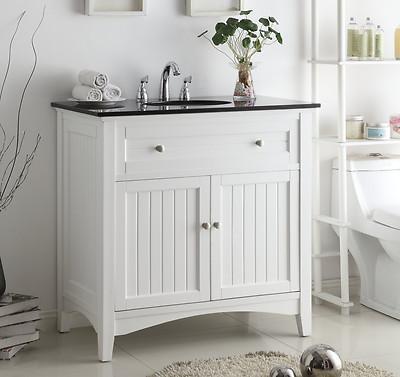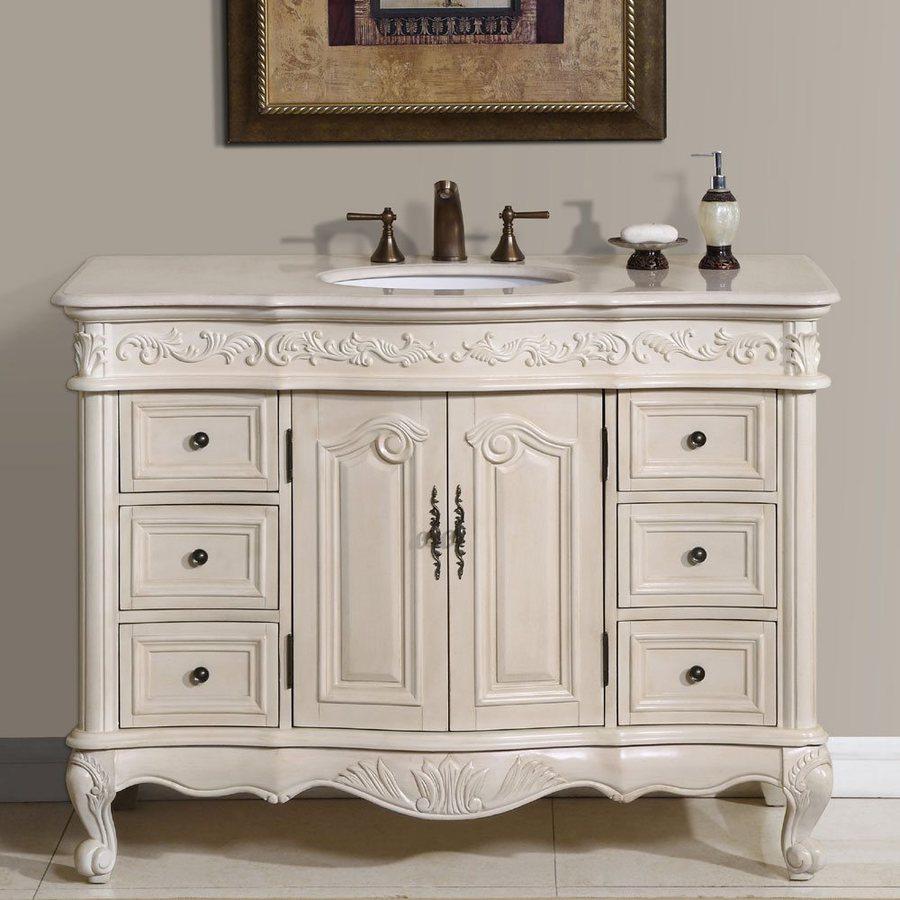The first image is the image on the left, the second image is the image on the right. Assess this claim about the two images: "Both sink cabinets are corner units.". Correct or not? Answer yes or no. No. The first image is the image on the left, the second image is the image on the right. Assess this claim about the two images: "One image shows a corner vanity with a white cabinet and an inset sink instead of a vessel sink.". Correct or not? Answer yes or no. No. 